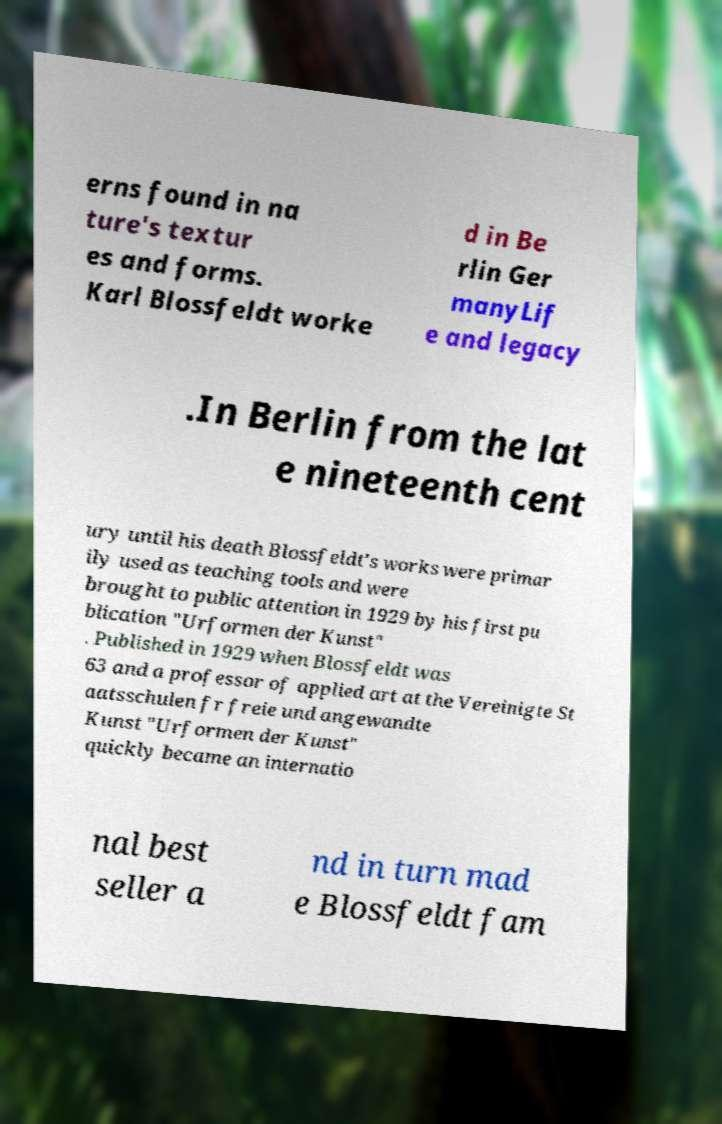Please identify and transcribe the text found in this image. erns found in na ture's textur es and forms. Karl Blossfeldt worke d in Be rlin Ger manyLif e and legacy .In Berlin from the lat e nineteenth cent ury until his death Blossfeldt's works were primar ily used as teaching tools and were brought to public attention in 1929 by his first pu blication "Urformen der Kunst" . Published in 1929 when Blossfeldt was 63 and a professor of applied art at the Vereinigte St aatsschulen fr freie und angewandte Kunst "Urformen der Kunst" quickly became an internatio nal best seller a nd in turn mad e Blossfeldt fam 